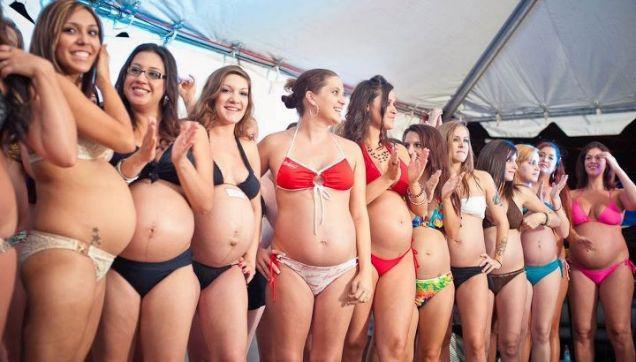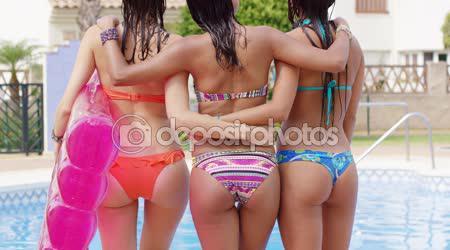The first image is the image on the left, the second image is the image on the right. For the images shown, is this caption "An image shows three bikini models side-by-side with backs turned to the camera." true? Answer yes or no. Yes. The first image is the image on the left, the second image is the image on the right. For the images shown, is this caption "In at least one image you can see a single woman in a all pink bikini with no additional colors on her suit." true? Answer yes or no. Yes. 